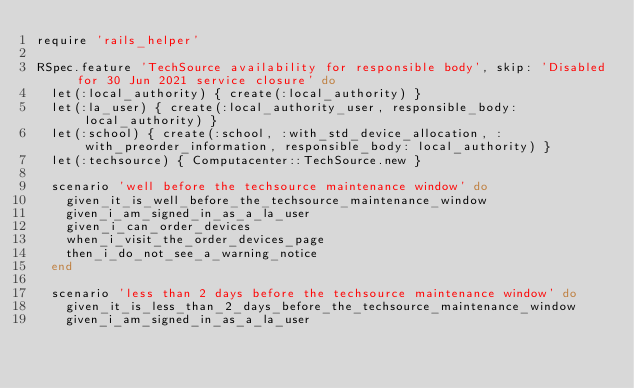<code> <loc_0><loc_0><loc_500><loc_500><_Ruby_>require 'rails_helper'

RSpec.feature 'TechSource availability for responsible body', skip: 'Disabled for 30 Jun 2021 service closure' do
  let(:local_authority) { create(:local_authority) }
  let(:la_user) { create(:local_authority_user, responsible_body: local_authority) }
  let(:school) { create(:school, :with_std_device_allocation, :with_preorder_information, responsible_body: local_authority) }
  let(:techsource) { Computacenter::TechSource.new }

  scenario 'well before the techsource maintenance window' do
    given_it_is_well_before_the_techsource_maintenance_window
    given_i_am_signed_in_as_a_la_user
    given_i_can_order_devices
    when_i_visit_the_order_devices_page
    then_i_do_not_see_a_warning_notice
  end

  scenario 'less than 2 days before the techsource maintenance window' do
    given_it_is_less_than_2_days_before_the_techsource_maintenance_window
    given_i_am_signed_in_as_a_la_user</code> 